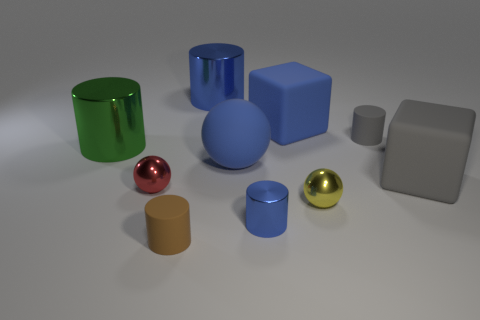Subtract all gray cylinders. How many cylinders are left? 4 Subtract all tiny gray cylinders. How many cylinders are left? 4 Subtract all purple cylinders. Subtract all purple blocks. How many cylinders are left? 5 Subtract all balls. How many objects are left? 7 Add 2 blue cylinders. How many blue cylinders exist? 4 Subtract 0 gray balls. How many objects are left? 10 Subtract all blue blocks. Subtract all large red cylinders. How many objects are left? 9 Add 2 big blue matte blocks. How many big blue matte blocks are left? 3 